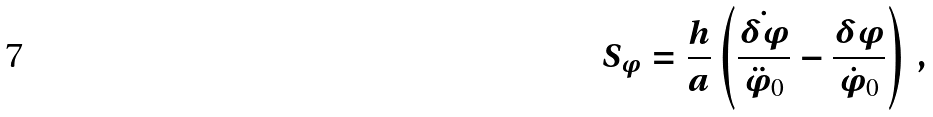<formula> <loc_0><loc_0><loc_500><loc_500>S _ { \varphi } = \frac { h } { a } \left ( \frac { \dot { \delta \varphi } } { \ddot { \varphi } _ { 0 } } - \frac { \delta \varphi } { \dot { \varphi } _ { 0 } } \right ) \, ,</formula> 